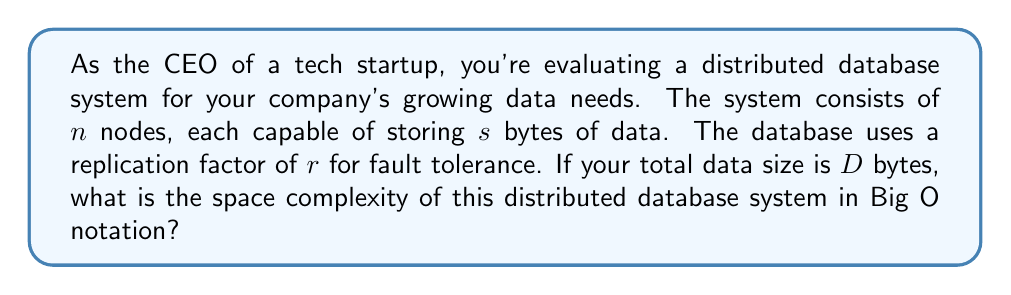Give your solution to this math problem. To evaluate the space complexity of this distributed database system, we need to consider the following factors:

1. Total number of nodes: $n$
2. Storage capacity per node: $s$ bytes
3. Replication factor: $r$
4. Total data size: $D$ bytes

Let's break down the analysis step by step:

1. Without replication, the space required would simply be $D$ bytes.

2. With a replication factor of $r$, each piece of data is stored $r$ times. So, the total space required becomes:

   $$\text{Total space} = D \times r$$

3. This total space is distributed across $n$ nodes. However, the space complexity is not dependent on the number of nodes, as it represents the worst-case space usage of the entire system.

4. The space complexity is determined by the total amount of data stored, including replicas. It grows linearly with the data size and the replication factor.

5. In Big O notation, we express this as $O(D \times r)$.

6. Since $r$ is typically a small constant (e.g., 3 or 5) and doesn't grow with the data size, we can simplify this to $O(D)$.

It's important to note that while the actual space used is $D \times r$, in Big O notation, we focus on the growth rate with respect to the input size (in this case, the data size $D$). Constants like $r$ are typically omitted in the final expression.
Answer: $O(D)$, where $D$ is the total data size in bytes. 